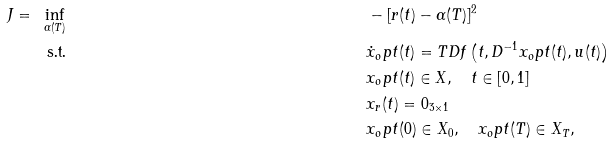<formula> <loc_0><loc_0><loc_500><loc_500>J = \ & \inf _ { \alpha ( T ) } & & - [ r ( t ) - \alpha ( T ) ] ^ { 2 } & \\ & \ \text {s.t.} & & \dot { x } _ { o } p t ( t ) = T D f \left ( t , D ^ { - 1 } x _ { o } p t ( t ) , u ( t ) \right ) & \\ & & & x _ { o } p t ( t ) \in X , \quad t \in [ 0 , 1 ] & \\ & & & x _ { r } ( t ) = 0 _ { 3 \times 1 } & \\ & & & x _ { o } p t ( 0 ) \in X _ { 0 } , \quad x _ { o } p t ( T ) \in X _ { T } , &</formula> 